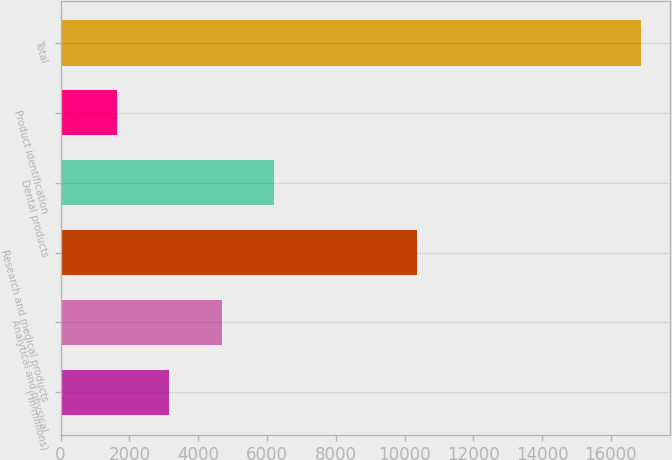Convert chart to OTSL. <chart><loc_0><loc_0><loc_500><loc_500><bar_chart><fcel>( in millions)<fcel>Analytical and physical<fcel>Research and medical products<fcel>Dental products<fcel>Product identification<fcel>Total<nl><fcel>3165.5<fcel>4689.6<fcel>10366.7<fcel>6213.7<fcel>1641.4<fcel>16882.4<nl></chart> 